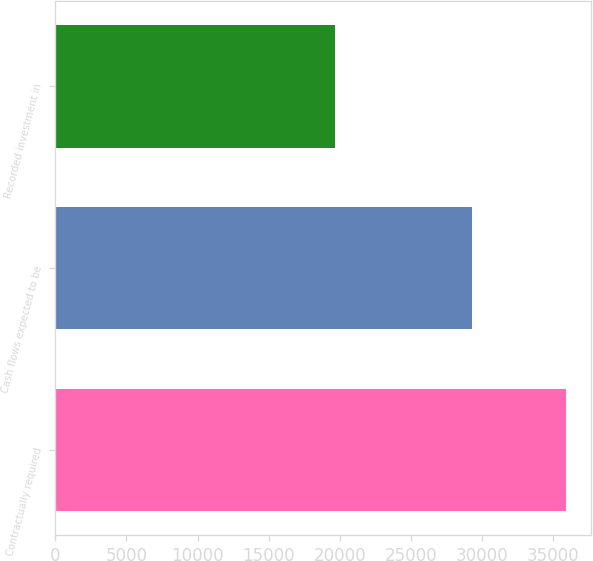<chart> <loc_0><loc_0><loc_500><loc_500><bar_chart><fcel>Contractually required<fcel>Cash flows expected to be<fcel>Recorded investment in<nl><fcel>35885<fcel>29314<fcel>19689<nl></chart> 